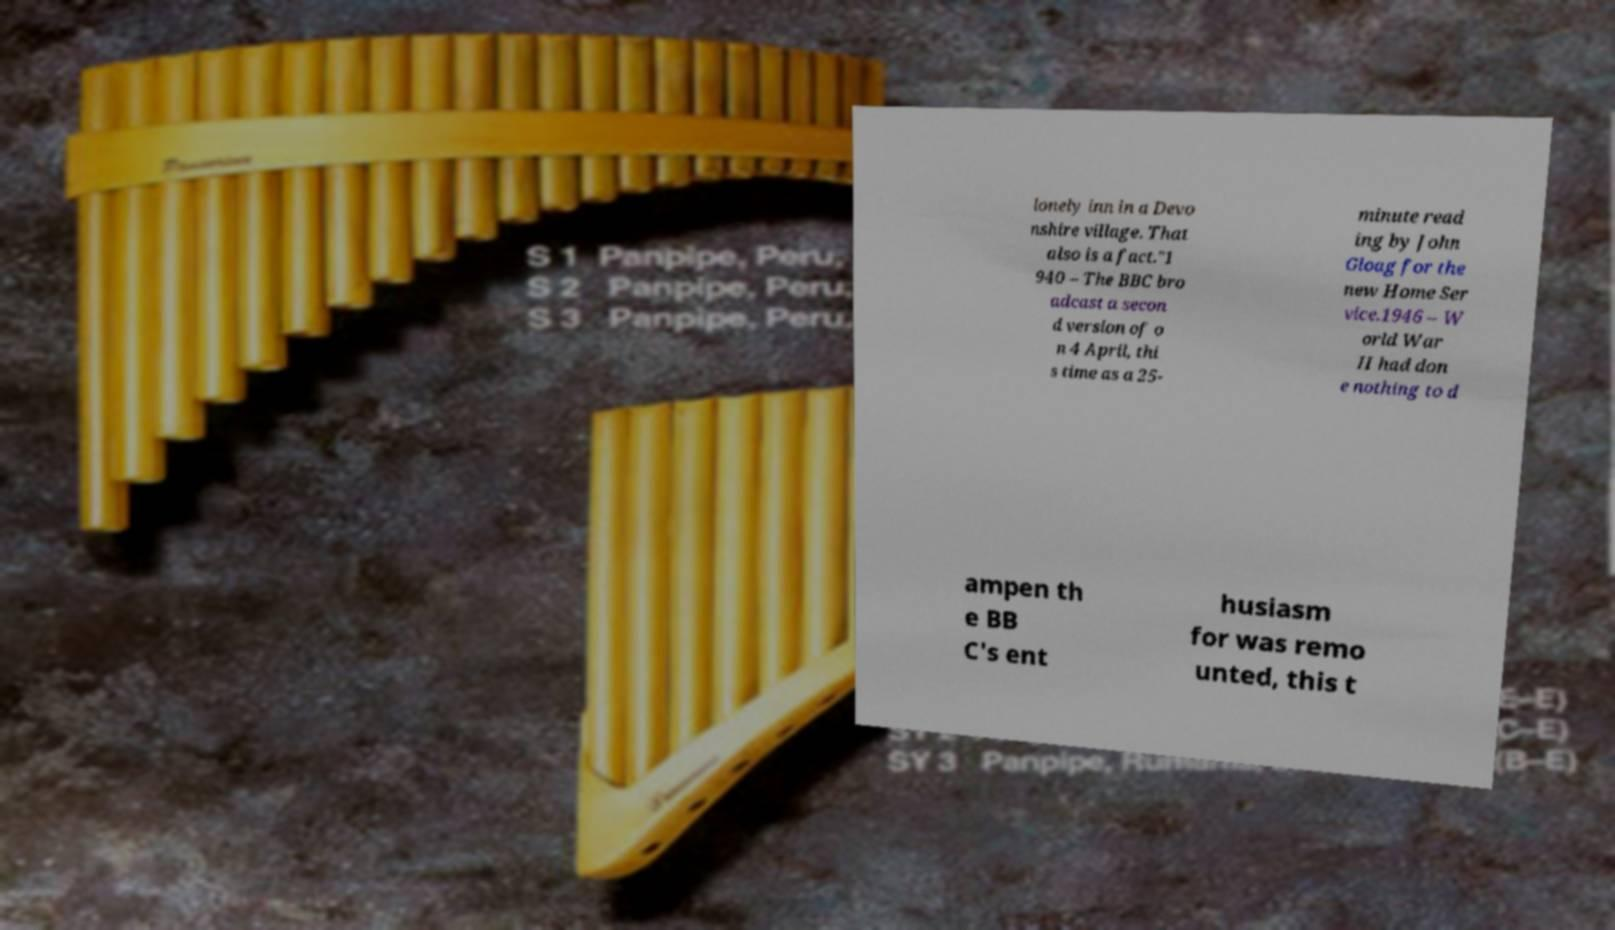Please read and relay the text visible in this image. What does it say? lonely inn in a Devo nshire village. That also is a fact."1 940 – The BBC bro adcast a secon d version of o n 4 April, thi s time as a 25- minute read ing by John Gloag for the new Home Ser vice.1946 – W orld War II had don e nothing to d ampen th e BB C's ent husiasm for was remo unted, this t 